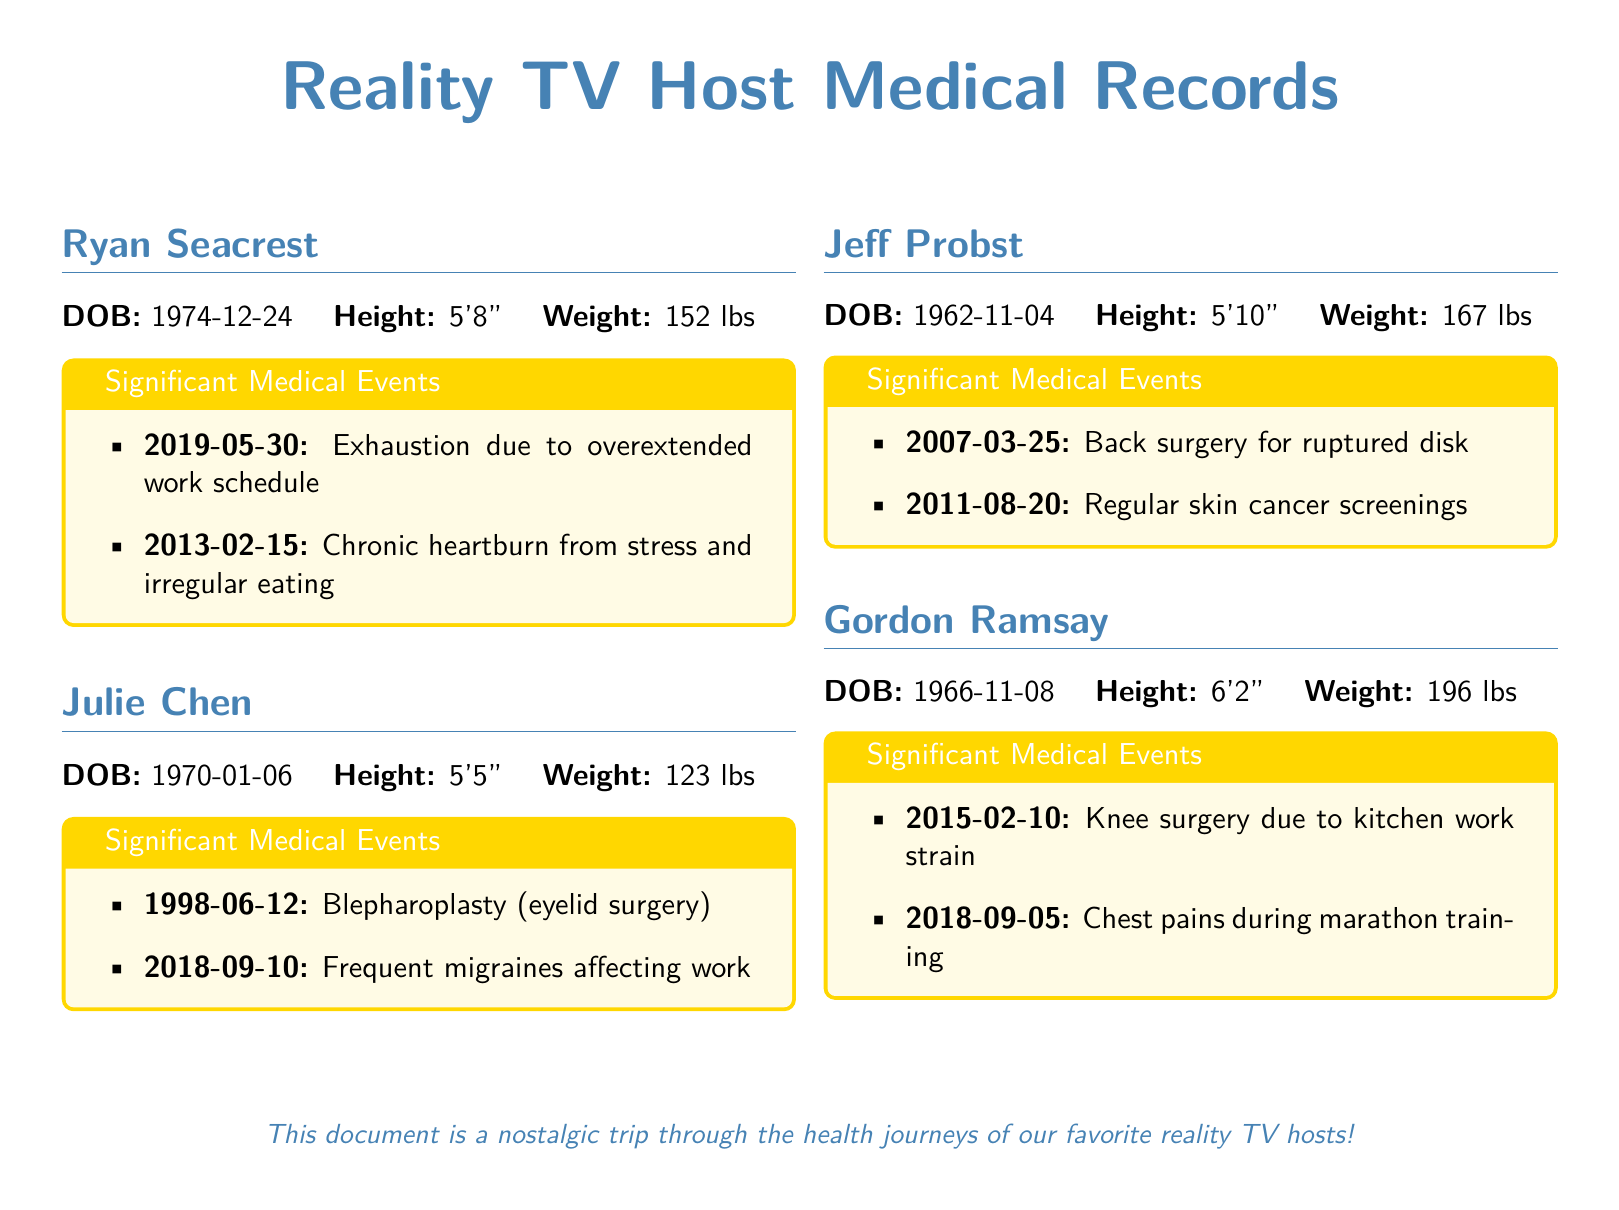What is Ryan Seacrest's date of birth? The document states Ryan Seacrest's date of birth as December 24, 1974.
Answer: 1974-12-24 What significant medical event occurred for Julie Chen in 1998? The document lists a blepharoplasty (eyelid surgery) as a significant medical event for Julie Chen on June 12, 1998.
Answer: Blepharoplasty What is Jeff Probst's weight? According to the document, Jeff Probst's weight is 167 lbs.
Answer: 167 lbs How tall is Gordon Ramsay? The document indicates that Gordon Ramsay is 6'2".
Answer: 6'2" What year did Ryan Seacrest experience exhaustion? The document mentions that Ryan Seacrest felt exhaustion due to an overextended work schedule in 2019.
Answer: 2019 Which reality TV host had frequent migraines? The document specifies that Julie Chen suffered from frequent migraines affecting her work.
Answer: Julie Chen How many medical events are listed for Jeff Probst? The document lists two significant medical events for Jeff Probst.
Answer: Two What was the cause of Gordon Ramsay's knee surgery? The document states the cause of Gordon Ramsay's knee surgery was kitchen work strain.
Answer: Kitchen work strain What type of document is this? The document is identified as a medical record of reality TV hosts.
Answer: Medical record 